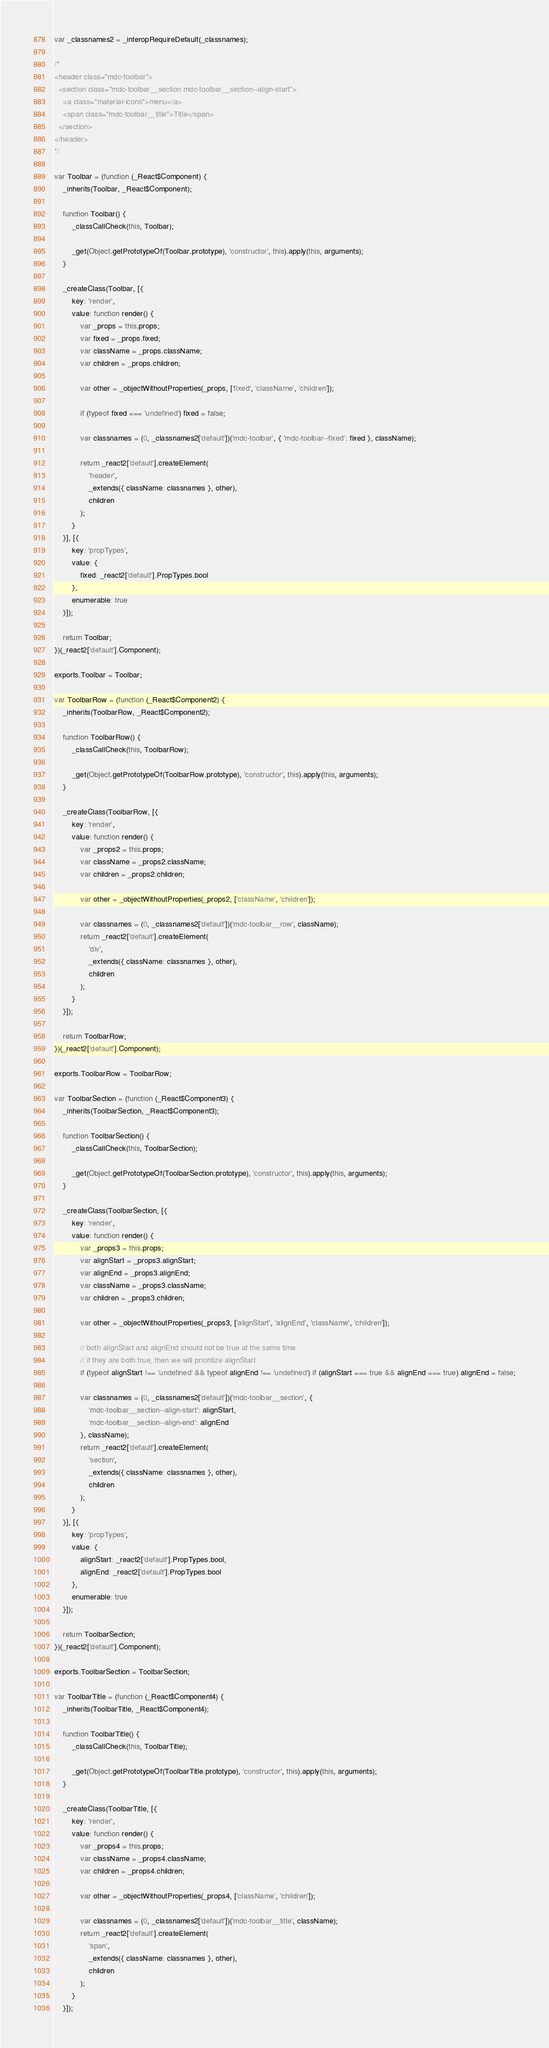Convert code to text. <code><loc_0><loc_0><loc_500><loc_500><_JavaScript_>var _classnames2 = _interopRequireDefault(_classnames);

/*
<header class="mdc-toolbar">
  <section class="mdc-toolbar__section mdc-toolbar__section--align-start">
    <a class="material-icons">menu</a>
    <span class="mdc-toolbar__title">Title</span>
  </section>
</header>
*/

var Toolbar = (function (_React$Component) {
    _inherits(Toolbar, _React$Component);

    function Toolbar() {
        _classCallCheck(this, Toolbar);

        _get(Object.getPrototypeOf(Toolbar.prototype), 'constructor', this).apply(this, arguments);
    }

    _createClass(Toolbar, [{
        key: 'render',
        value: function render() {
            var _props = this.props;
            var fixed = _props.fixed;
            var className = _props.className;
            var children = _props.children;

            var other = _objectWithoutProperties(_props, ['fixed', 'className', 'children']);

            if (typeof fixed === 'undefined') fixed = false;

            var classnames = (0, _classnames2['default'])('mdc-toolbar', { 'mdc-toolbar--fixed': fixed }, className);

            return _react2['default'].createElement(
                'header',
                _extends({ className: classnames }, other),
                children
            );
        }
    }], [{
        key: 'propTypes',
        value: {
            fixed: _react2['default'].PropTypes.bool
        },
        enumerable: true
    }]);

    return Toolbar;
})(_react2['default'].Component);

exports.Toolbar = Toolbar;

var ToolbarRow = (function (_React$Component2) {
    _inherits(ToolbarRow, _React$Component2);

    function ToolbarRow() {
        _classCallCheck(this, ToolbarRow);

        _get(Object.getPrototypeOf(ToolbarRow.prototype), 'constructor', this).apply(this, arguments);
    }

    _createClass(ToolbarRow, [{
        key: 'render',
        value: function render() {
            var _props2 = this.props;
            var className = _props2.className;
            var children = _props2.children;

            var other = _objectWithoutProperties(_props2, ['className', 'children']);

            var classnames = (0, _classnames2['default'])('mdc-toolbar__row', className);
            return _react2['default'].createElement(
                'div',
                _extends({ className: classnames }, other),
                children
            );
        }
    }]);

    return ToolbarRow;
})(_react2['default'].Component);

exports.ToolbarRow = ToolbarRow;

var ToolbarSection = (function (_React$Component3) {
    _inherits(ToolbarSection, _React$Component3);

    function ToolbarSection() {
        _classCallCheck(this, ToolbarSection);

        _get(Object.getPrototypeOf(ToolbarSection.prototype), 'constructor', this).apply(this, arguments);
    }

    _createClass(ToolbarSection, [{
        key: 'render',
        value: function render() {
            var _props3 = this.props;
            var alignStart = _props3.alignStart;
            var alignEnd = _props3.alignEnd;
            var className = _props3.className;
            var children = _props3.children;

            var other = _objectWithoutProperties(_props3, ['alignStart', 'alignEnd', 'className', 'children']);

            // both alignStart and alignEnd should not be true at the same time
            // if they are both true, then we will prioritize alignStart
            if (typeof alignStart !== 'undefined' && typeof alignEnd !== 'undefined') if (alignStart === true && alignEnd === true) alignEnd = false;

            var classnames = (0, _classnames2['default'])('mdc-toolbar__section', {
                'mdc-toolbar__section--align-start': alignStart,
                'mdc-toolbar__section--align-end': alignEnd
            }, className);
            return _react2['default'].createElement(
                'section',
                _extends({ className: classnames }, other),
                children
            );
        }
    }], [{
        key: 'propTypes',
        value: {
            alignStart: _react2['default'].PropTypes.bool,
            alignEnd: _react2['default'].PropTypes.bool
        },
        enumerable: true
    }]);

    return ToolbarSection;
})(_react2['default'].Component);

exports.ToolbarSection = ToolbarSection;

var ToolbarTitle = (function (_React$Component4) {
    _inherits(ToolbarTitle, _React$Component4);

    function ToolbarTitle() {
        _classCallCheck(this, ToolbarTitle);

        _get(Object.getPrototypeOf(ToolbarTitle.prototype), 'constructor', this).apply(this, arguments);
    }

    _createClass(ToolbarTitle, [{
        key: 'render',
        value: function render() {
            var _props4 = this.props;
            var className = _props4.className;
            var children = _props4.children;

            var other = _objectWithoutProperties(_props4, ['className', 'children']);

            var classnames = (0, _classnames2['default'])('mdc-toolbar__title', className);
            return _react2['default'].createElement(
                'span',
                _extends({ className: classnames }, other),
                children
            );
        }
    }]);
</code> 